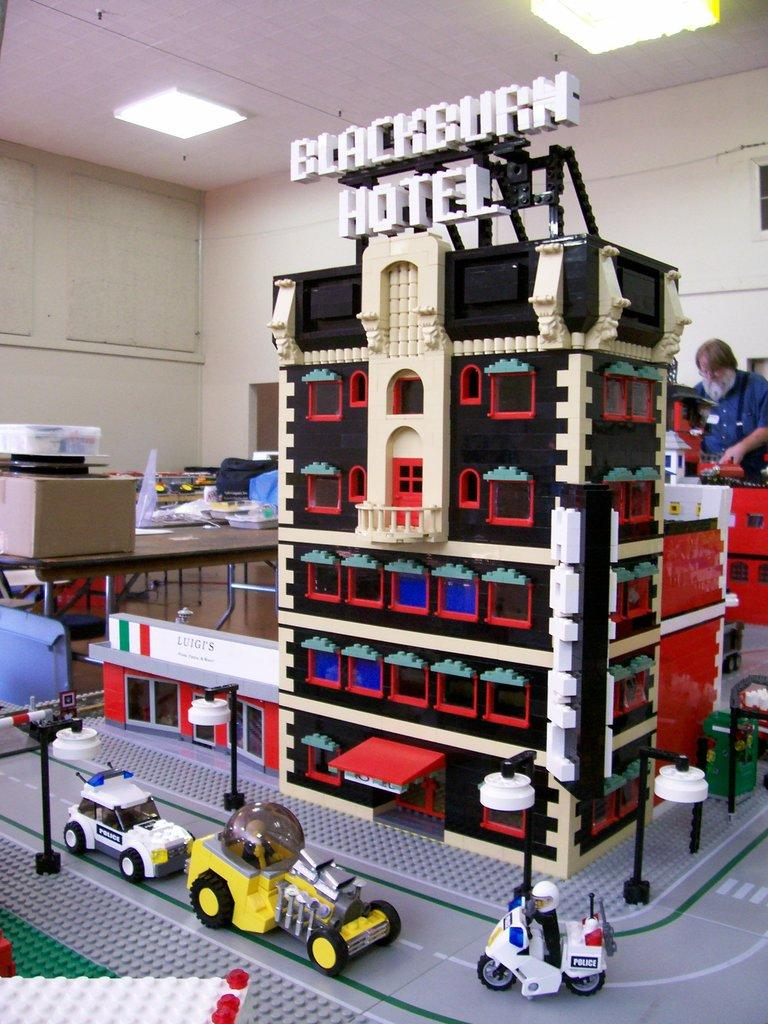What is the main subject of the image? The main subject of the image is a house building module. What other objects are present in the image? There are toy vehicles in the image. Can you describe the person in the image? There is a man standing in the background of the image. What can be seen on the ceiling in the image? There are lights on the ceiling in the image. What type of bubble can be seen floating around the house building module in the image? There is no bubble present in the image; it only features a house building module, toy vehicles, a man in the background, and lights on the ceiling. 